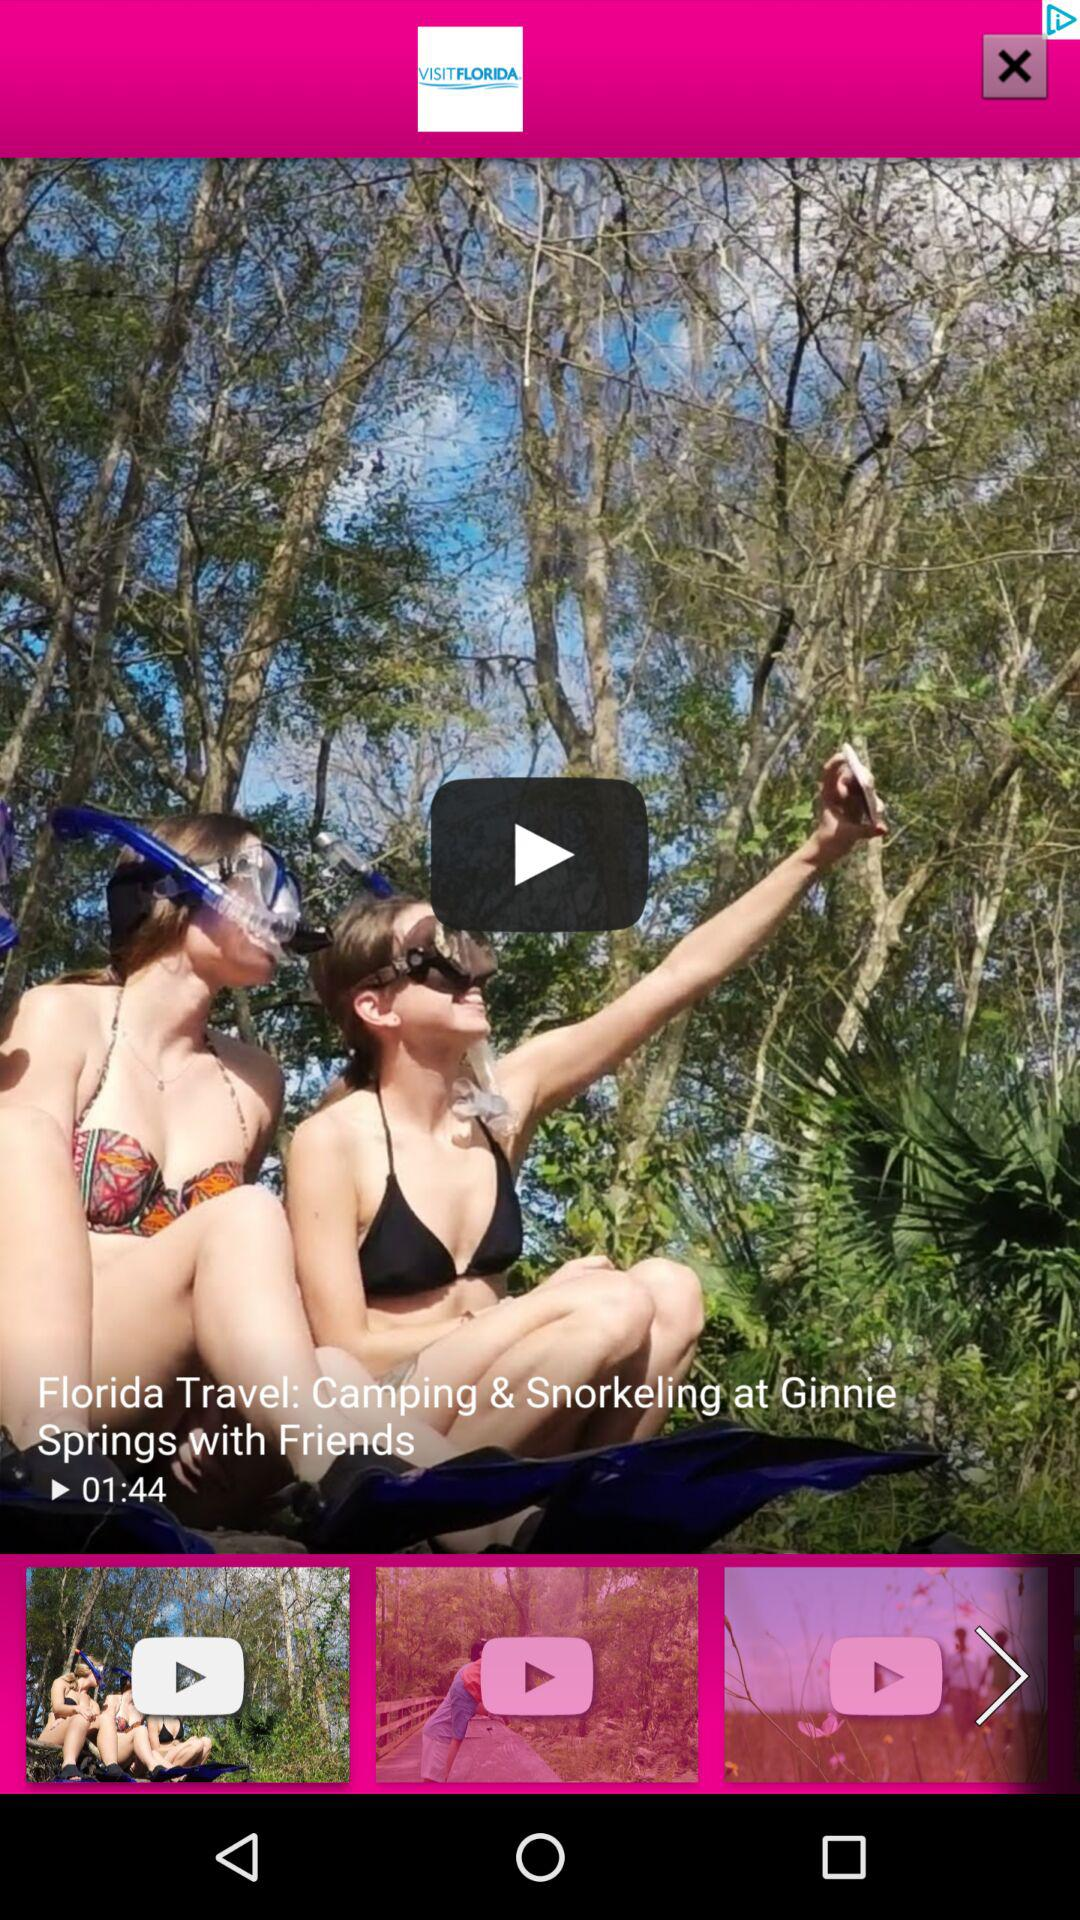What is the duration of the video? The duration of the video is 01:44. 